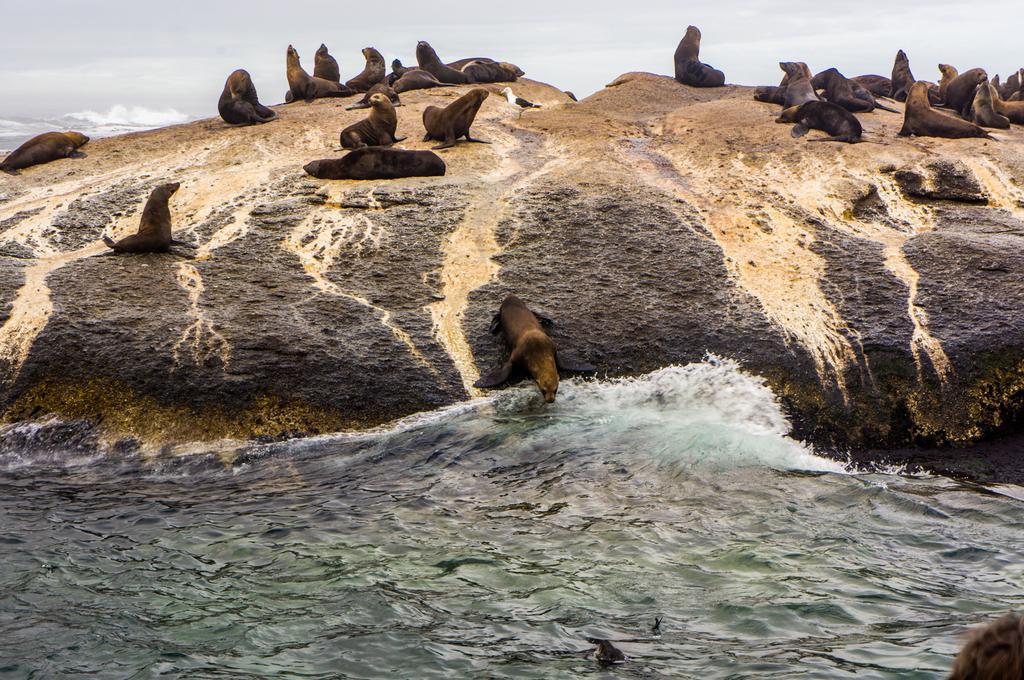Could you give a brief overview of what you see in this image? This picture is clicked outside the city. In the foreground there is a water body. In the center we can see the group of sea lions sitting on the rock and there is a bird standing on the rock. In the background there is a sky. 